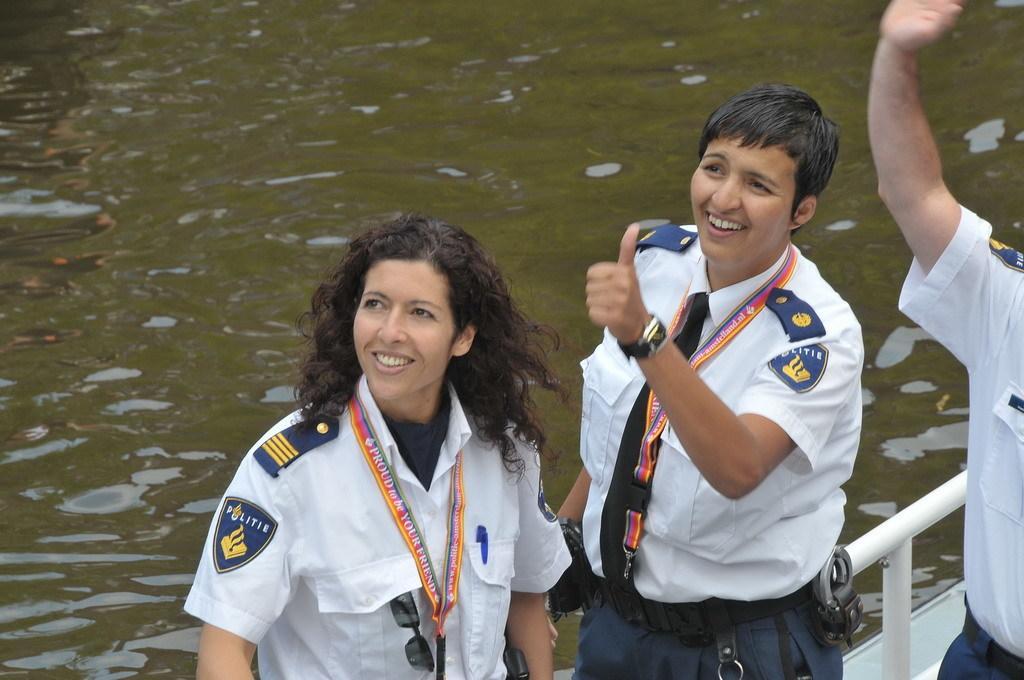Describe this image in one or two sentences. In this picture I can see a boat on the water, and there are three persons standing on the boat. 